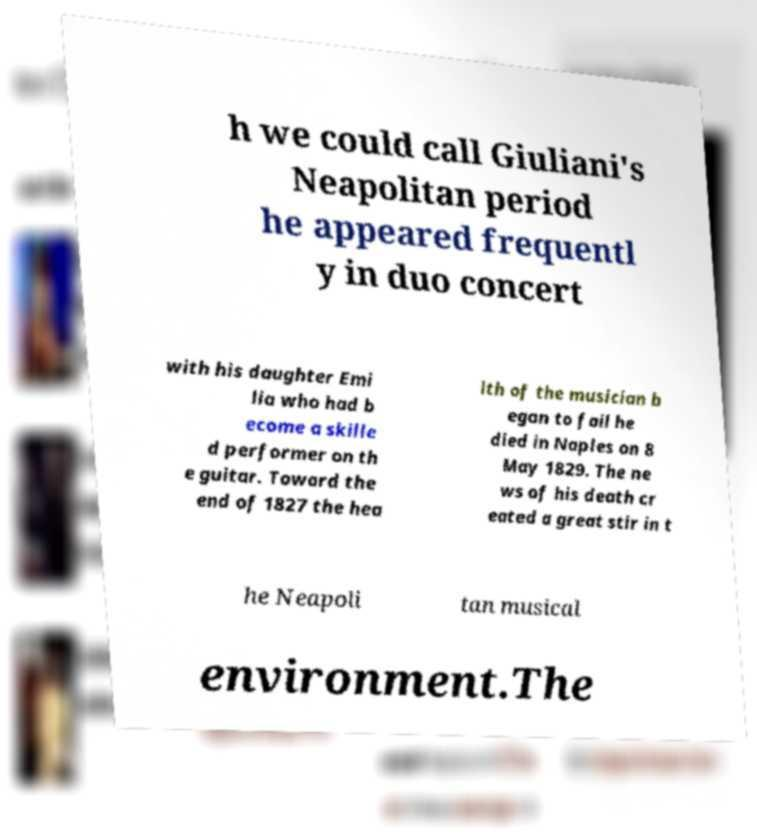Could you extract and type out the text from this image? h we could call Giuliani's Neapolitan period he appeared frequentl y in duo concert with his daughter Emi lia who had b ecome a skille d performer on th e guitar. Toward the end of 1827 the hea lth of the musician b egan to fail he died in Naples on 8 May 1829. The ne ws of his death cr eated a great stir in t he Neapoli tan musical environment.The 